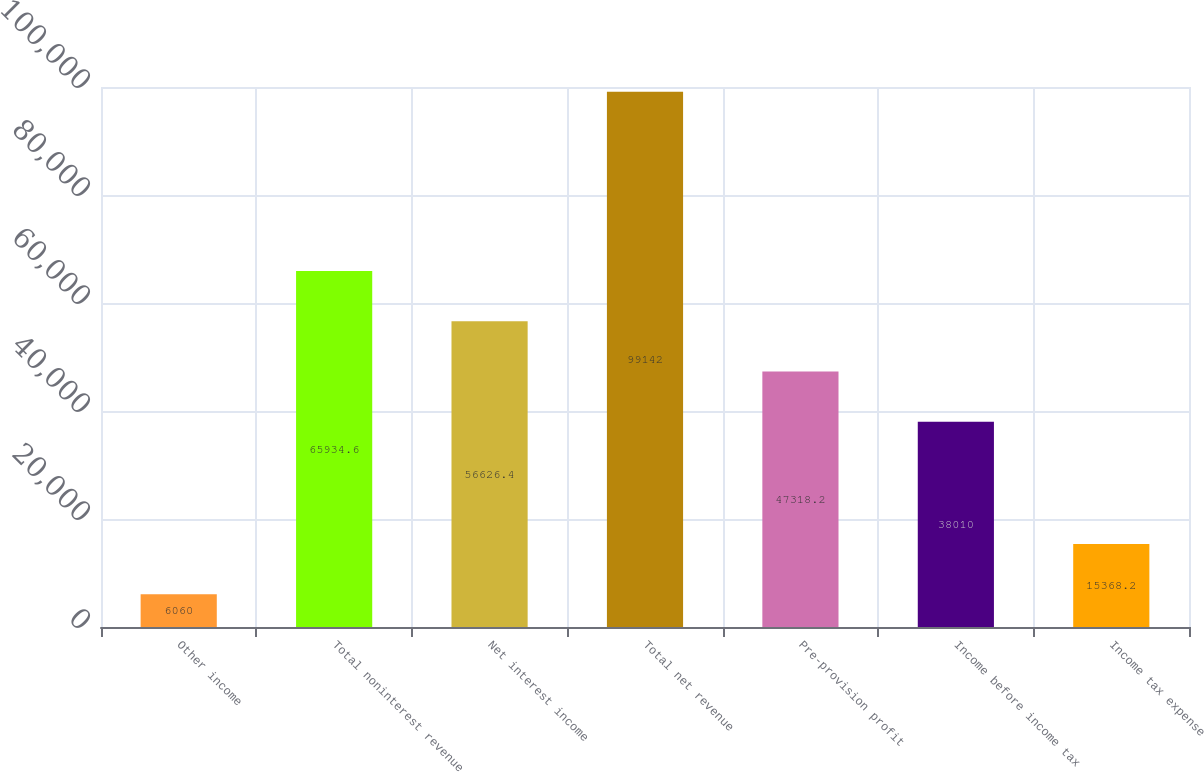Convert chart. <chart><loc_0><loc_0><loc_500><loc_500><bar_chart><fcel>Other income<fcel>Total noninterest revenue<fcel>Net interest income<fcel>Total net revenue<fcel>Pre-provision profit<fcel>Income before income tax<fcel>Income tax expense<nl><fcel>6060<fcel>65934.6<fcel>56626.4<fcel>99142<fcel>47318.2<fcel>38010<fcel>15368.2<nl></chart> 